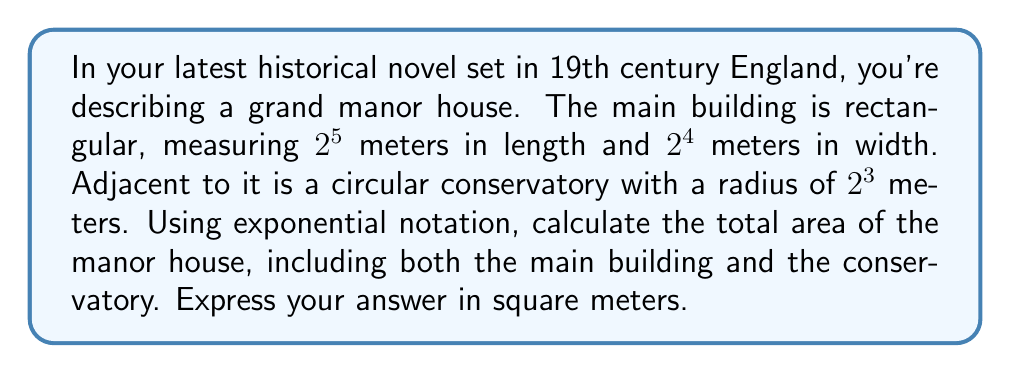Help me with this question. Let's break this problem down step by step:

1) First, we need to calculate the area of the main building:
   - Length = $2^5$ meters
   - Width = $2^4$ meters
   - Area of rectangle = length × width
   - Area of main building = $2^5 \times 2^4 = 2^{5+4} = 2^9$ square meters

2) Next, we calculate the area of the circular conservatory:
   - Radius = $2^3$ meters
   - Area of circle = $\pi r^2$
   - Area of conservatory = $\pi (2^3)^2 = \pi \times 2^6$ square meters

3) Now, we add these areas together:
   - Total area = Area of main building + Area of conservatory
   - Total area = $2^9 + \pi \times 2^6$ square meters

4) To simplify this further, we can factor out $2^6$:
   - Total area = $2^9 + \pi \times 2^6$
                = $2^6 \times 2^3 + \pi \times 2^6$
                = $2^6 (2^3 + \pi)$ square meters

This is the most simplified form using exponential notation.
Answer: $2^6 (2^3 + \pi)$ square meters 